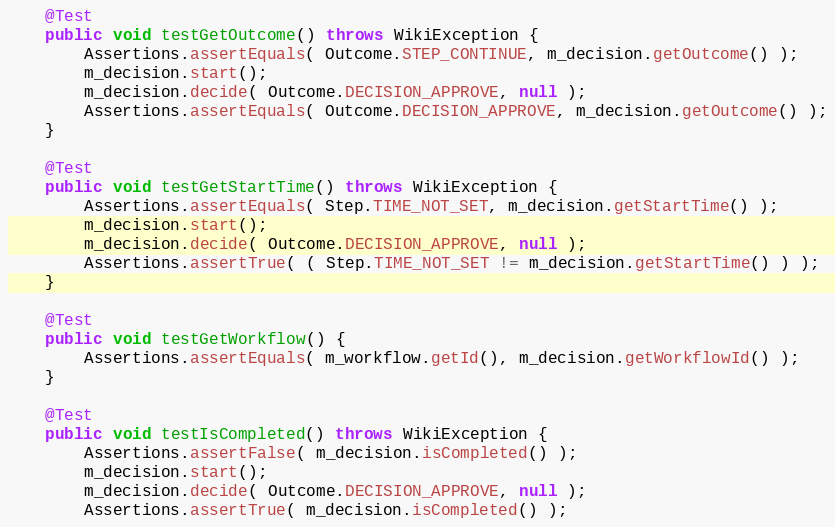<code> <loc_0><loc_0><loc_500><loc_500><_Java_>
    @Test
    public void testGetOutcome() throws WikiException {
        Assertions.assertEquals( Outcome.STEP_CONTINUE, m_decision.getOutcome() );
        m_decision.start();
        m_decision.decide( Outcome.DECISION_APPROVE, null );
        Assertions.assertEquals( Outcome.DECISION_APPROVE, m_decision.getOutcome() );
    }

    @Test
    public void testGetStartTime() throws WikiException {
        Assertions.assertEquals( Step.TIME_NOT_SET, m_decision.getStartTime() );
        m_decision.start();
        m_decision.decide( Outcome.DECISION_APPROVE, null );
        Assertions.assertTrue( ( Step.TIME_NOT_SET != m_decision.getStartTime() ) );
    }

    @Test
    public void testGetWorkflow() {
        Assertions.assertEquals( m_workflow.getId(), m_decision.getWorkflowId() );
    }

    @Test
    public void testIsCompleted() throws WikiException {
        Assertions.assertFalse( m_decision.isCompleted() );
        m_decision.start();
        m_decision.decide( Outcome.DECISION_APPROVE, null );
        Assertions.assertTrue( m_decision.isCompleted() );</code> 